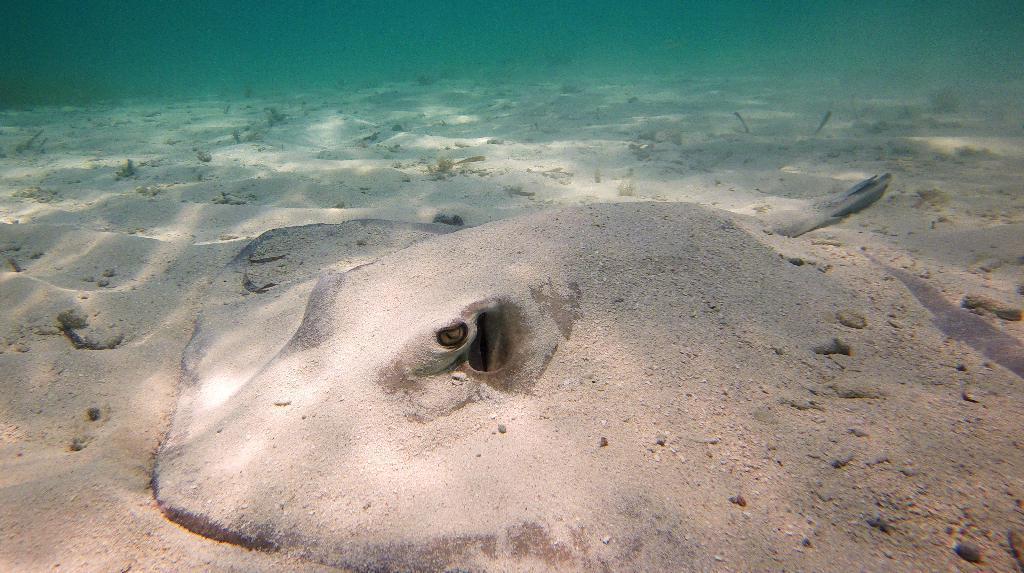In one or two sentences, can you explain what this image depicts? This image consists of an aquatic animal. It is clicked in an ocean. At the bottom, there is sand. At the top, there is water. 